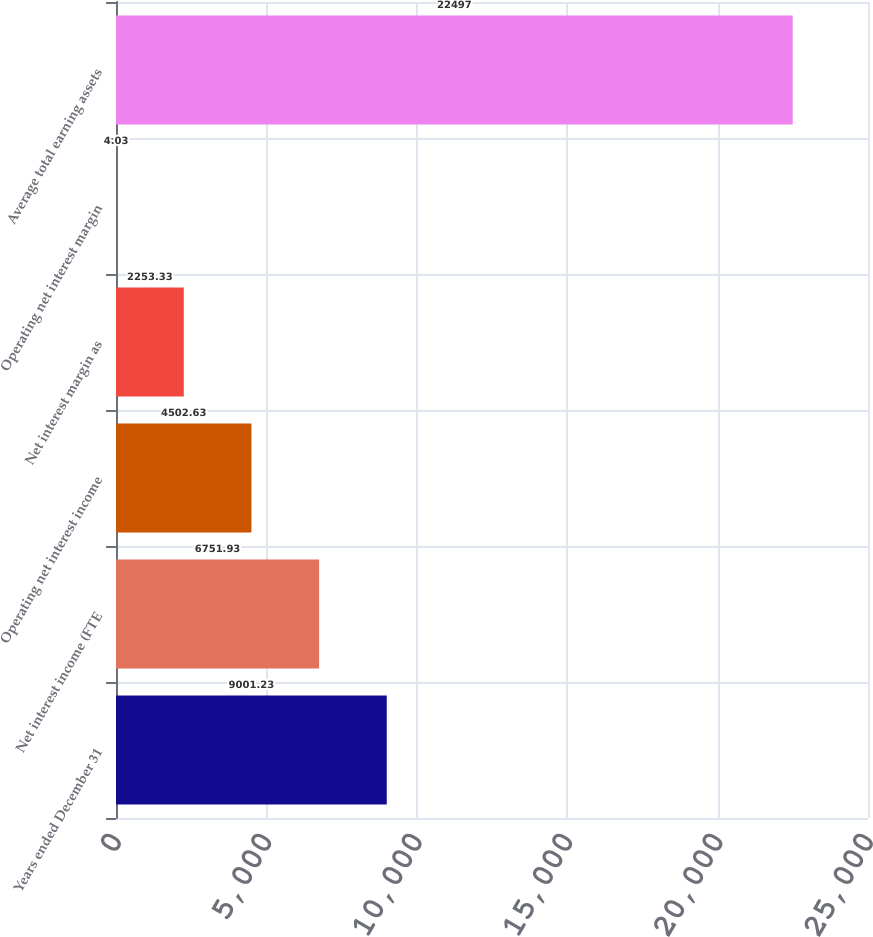<chart> <loc_0><loc_0><loc_500><loc_500><bar_chart><fcel>Years ended December 31<fcel>Net interest income (FTE<fcel>Operating net interest income<fcel>Net interest margin as<fcel>Operating net interest margin<fcel>Average total earning assets<nl><fcel>9001.23<fcel>6751.93<fcel>4502.63<fcel>2253.33<fcel>4.03<fcel>22497<nl></chart> 